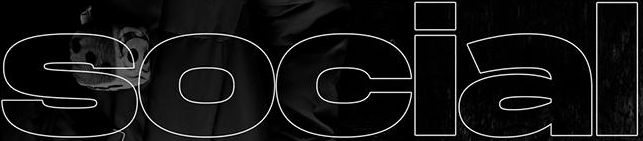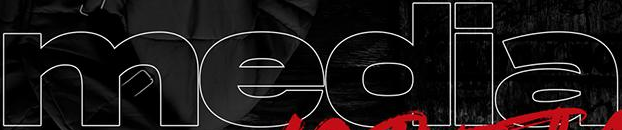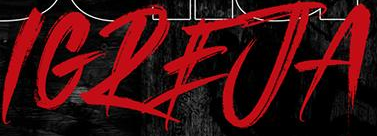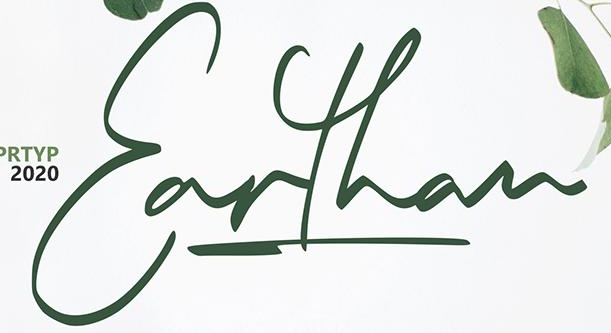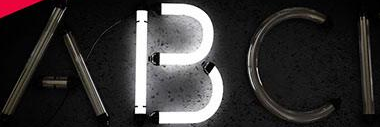What text appears in these images from left to right, separated by a semicolon? social; media; IGREJA; Earthan; ABCI 